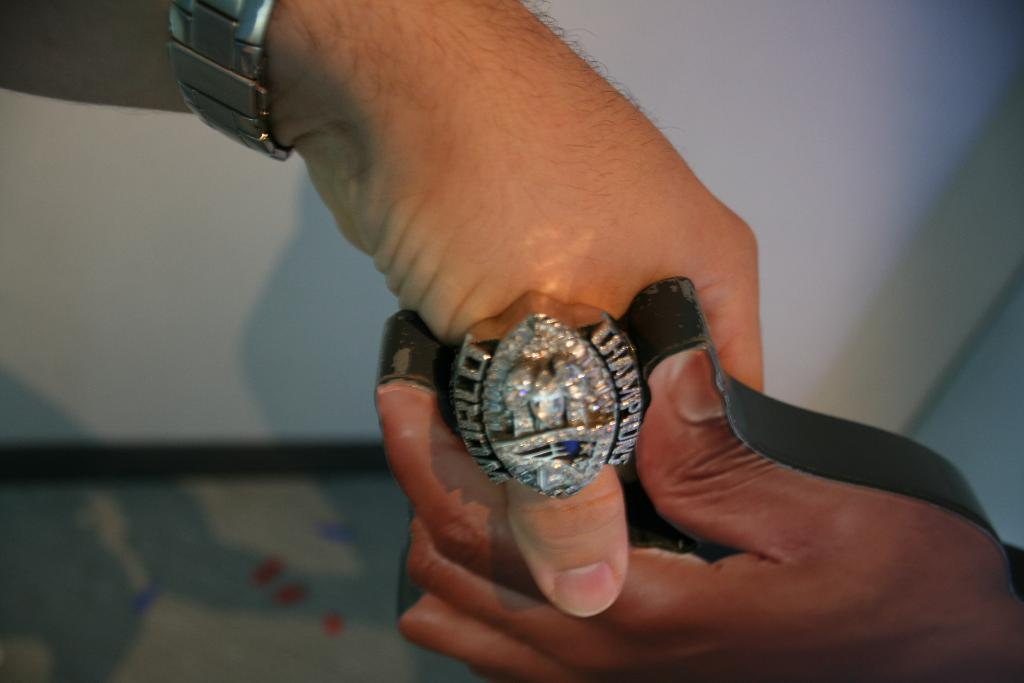<image>
Write a terse but informative summary of the picture. A person wearing a ring that says World Champions on it. 